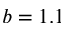<formula> <loc_0><loc_0><loc_500><loc_500>b = 1 . 1</formula> 